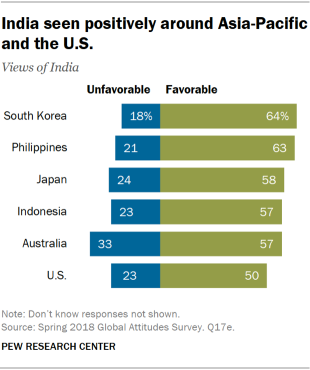Outline some significant characteristics in this image. The green bar signifies a favorable outcome. The ratio of unfavorable to favorable opinions in South Korea is approximately 0.397222222222222222222222222222222222222222222222222222222222222222222222222222222222222222222222222222222222222222222222222222222222222222222222222222222222222222222222222222222222222222222222222222222222222222222222222222222222222222222222222222222222222222222222222222222222222222222222222222222222222222222222222222222222222222222222222222222222222222222222222222222222222222222222222222222222222222222222222222222222222222222222222222222222222222222222222222222222222222222222222222222222222222222222222222222222222222222222222222222222222222222222222222222222222222222222222222222222222222222222222222222222222222222222222222222222222222222222222222222222222222222222222222222222222222222222222222222222222222222222222222222222222222222222222222222222222222222222222222222222222222222222222222222222222222222222 